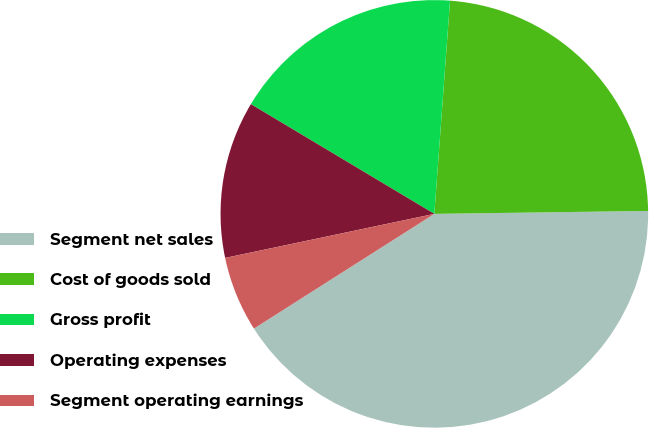<chart> <loc_0><loc_0><loc_500><loc_500><pie_chart><fcel>Segment net sales<fcel>Cost of goods sold<fcel>Gross profit<fcel>Operating expenses<fcel>Segment operating earnings<nl><fcel>41.2%<fcel>23.61%<fcel>17.59%<fcel>11.88%<fcel>5.71%<nl></chart> 